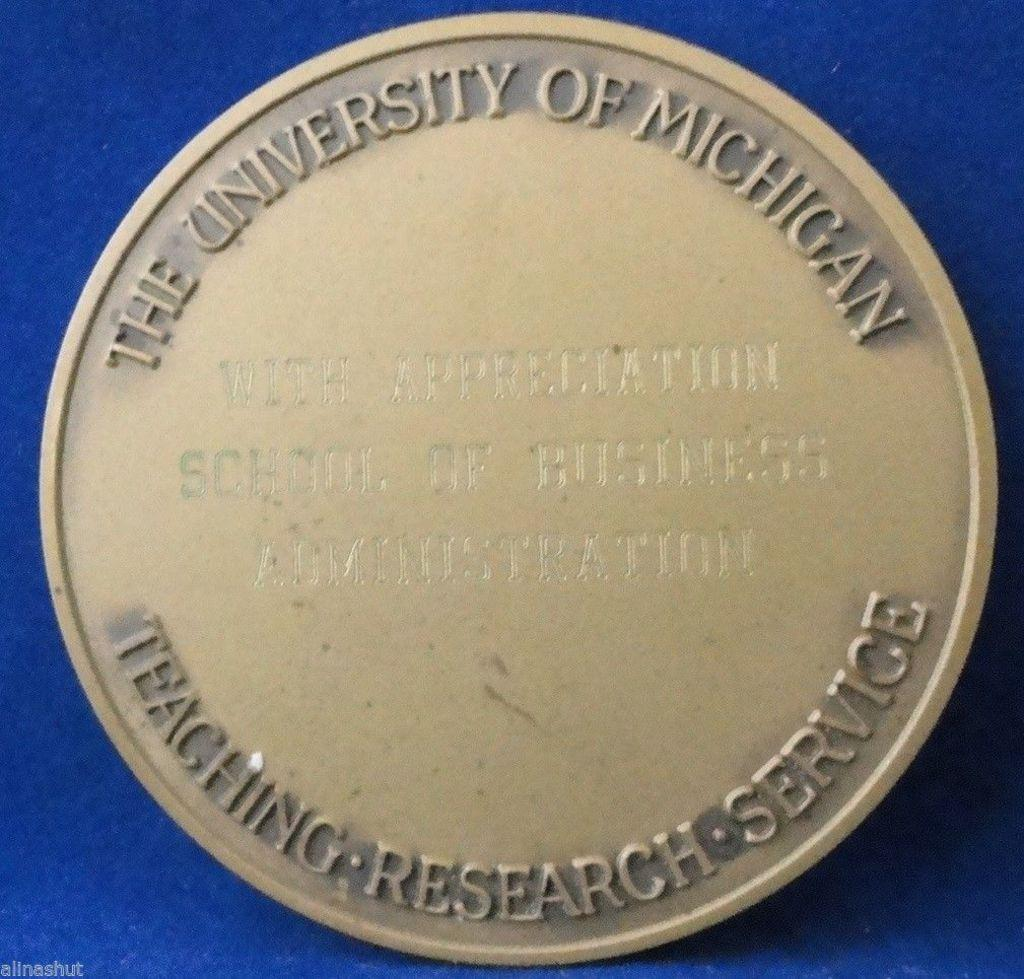<image>
Provide a brief description of the given image. A gold sign with The University of Michigan Teaching Research Service on it. 